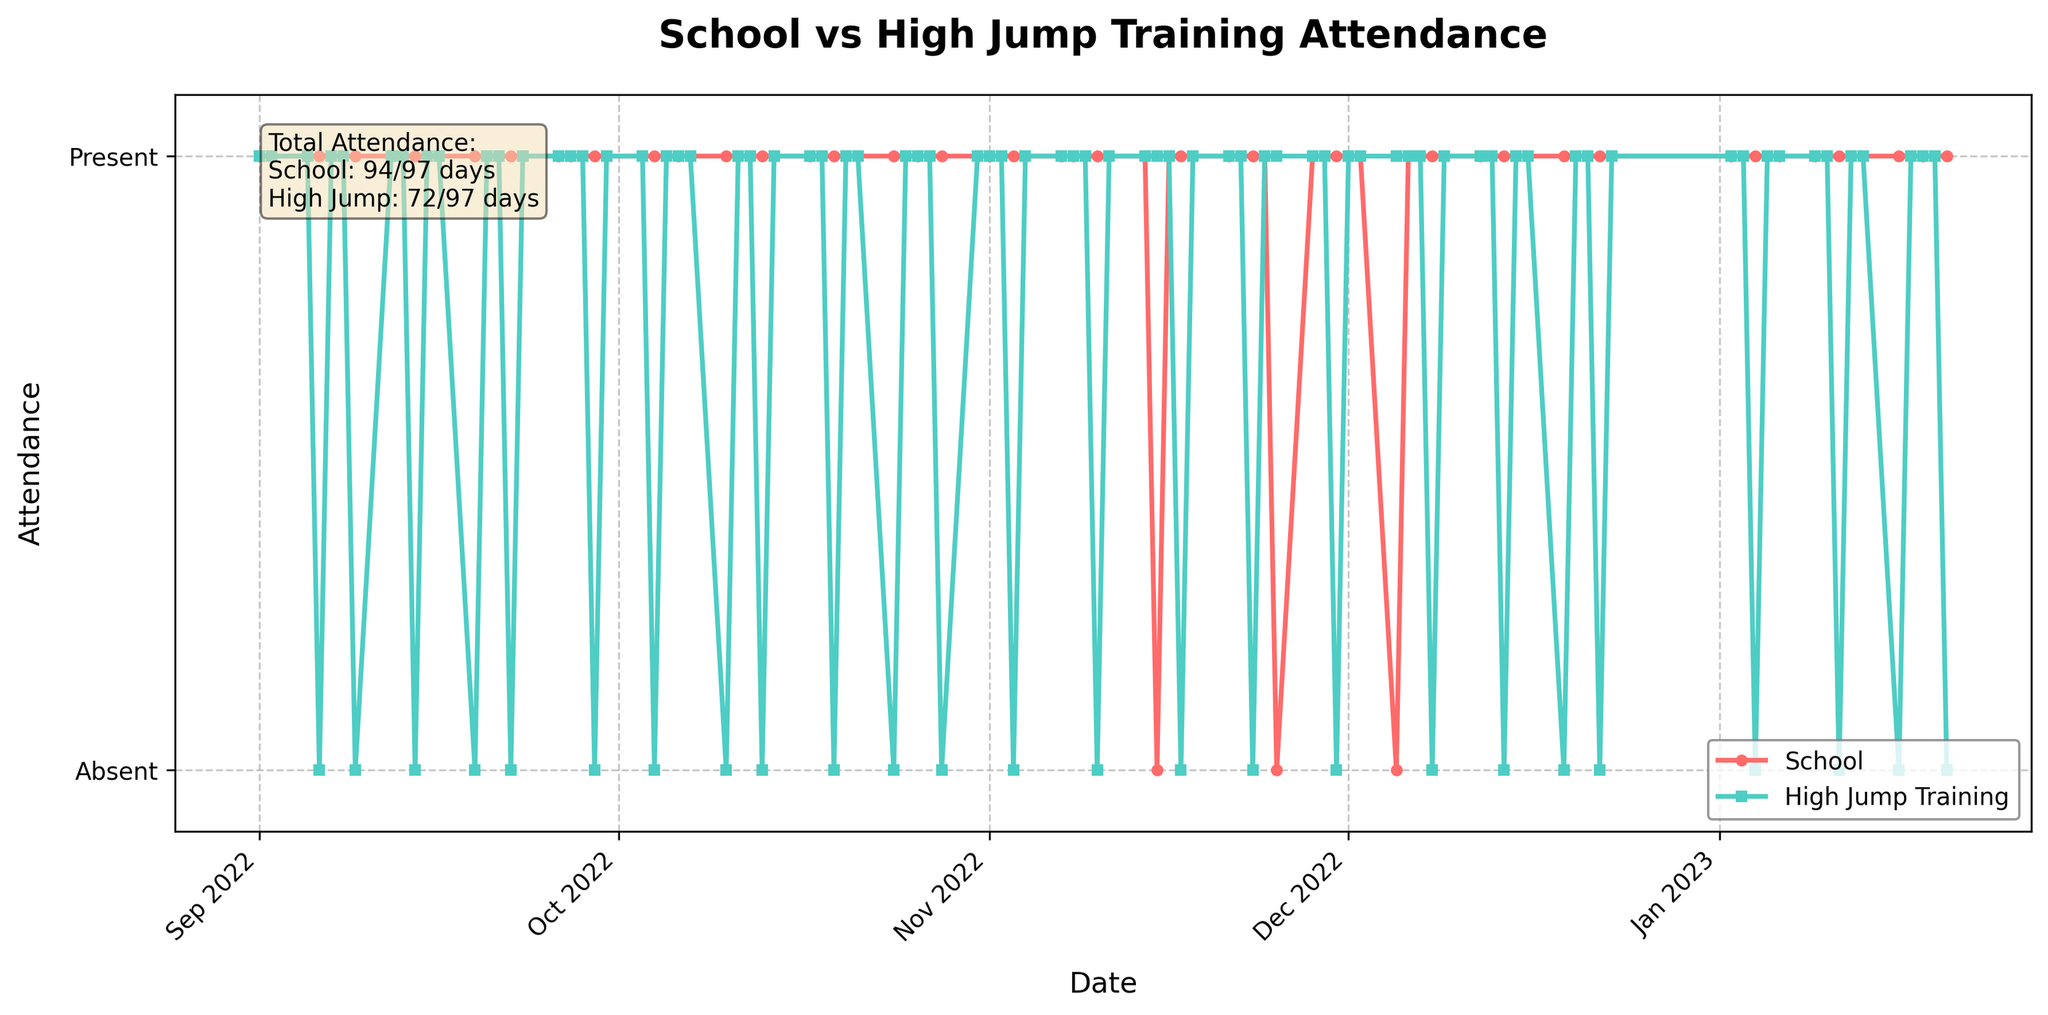What is the title of the plot? The title is located at the top of the plot. It usually summarizes the contents of the figure. Here, it reads "School vs High Jump Training Attendance".
Answer: School vs High Jump Training Attendance What colors are used to represent School Attendance and High Jump Training Attendance? The plot uses different colors to distinguish between the two attendance types: School Attendance is in red circles, while High Jump Training Attendance is in green squares.
Answer: Red and Green How many total days of attendance data are displayed in the plot? The text box within the plot indicates the total number of days by showing the total attendance counts for both school and high jump training. In this case, it shows there are 102 days of attendance data.
Answer: 102 days Which type of attendance had more days present overall? To determine which attendance type had more days present, one can refer to the text box in the plot that displays the total attendance for School and High Jump Training.
Answer: School How often does high jump training attendance drop to zero compared to school attendance? By looking at the plot, you can count the number of times the high jump attendance line drops to zero versus the school attendance line. Markers below the x-axis also indicate this.
Answer: High Jump: 20 times; School: 3 times On which dates did both School and High Jump Training have no attendance recorded? We need to find the dates where both lines drop to zero simultaneously. However, based on the plot data, this scenario does not occur. This happens because the data points are plotted, and none show both at zero simultaneously.
Answer: None What is the general trend for School Attendance over time? The red line representing School Attendance is consistently at the top level throughout the plot, indicating a consistently high attendance with few drops to zero across the months.
Answer: Consistent During which month does High Jump Training attendance show the most variability? Look for months where the green line for High Jump Training Attendance fluctuates the most. November and December show frequent shifts between present and absent.
Answer: November and December What is the difference in the total number of absence days between School and High Jump Training? To find the difference, subtract the total days present from the total days (102) for both school and high jump training and compare. School was absent for 3 days (102-99), and High Jump Training was absent for 20 days (102-82), so the difference is 20 - 3.
Answer: 17 days Is there a period where High Jump Training Attendance is continuously present without any absence? Check the green line for consecutive stretches where it remains at the top level without dropping to zero. The longest continuous stretch is in early October, where it remains present from October 1st to October 7th.
Answer: October 1st to October 7th 